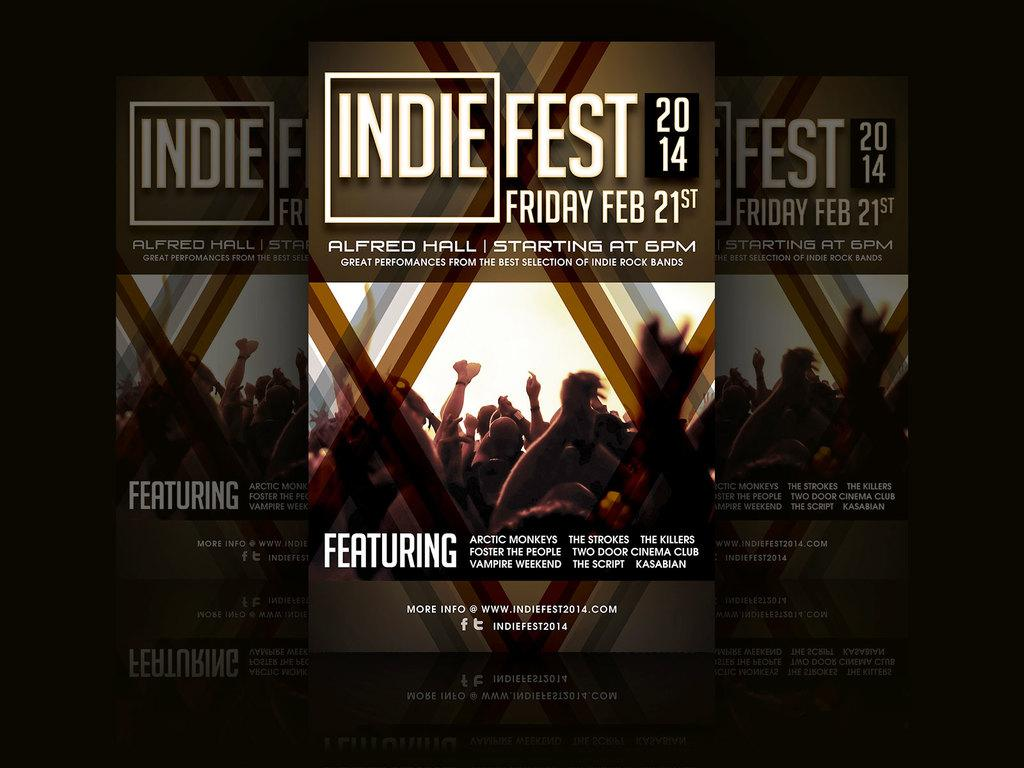<image>
Present a compact description of the photo's key features. A poster advertising an Indie Fest on the 21st of February. 